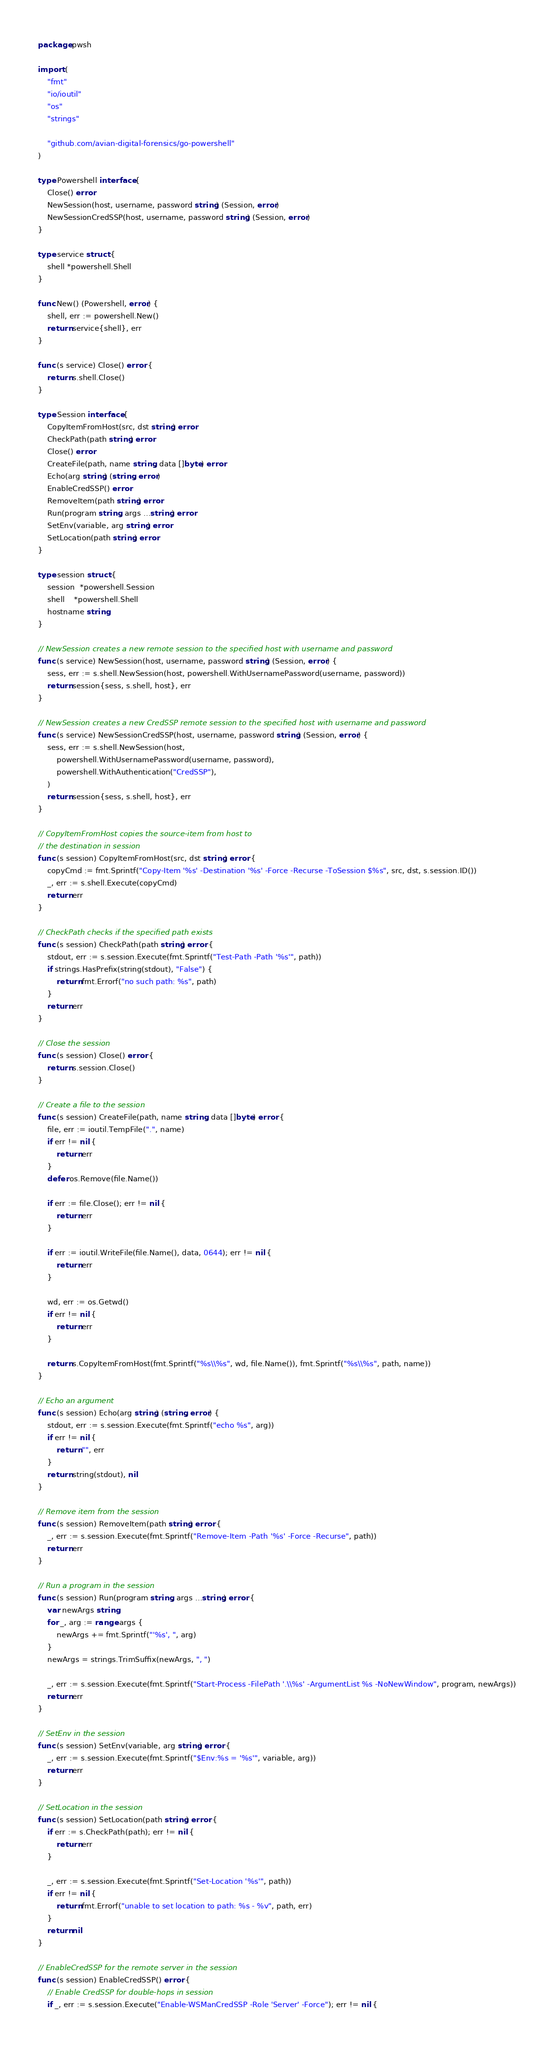<code> <loc_0><loc_0><loc_500><loc_500><_Go_>package pwsh

import (
	"fmt"
	"io/ioutil"
	"os"
	"strings"

	"github.com/avian-digital-forensics/go-powershell"
)

type Powershell interface {
	Close() error
	NewSession(host, username, password string) (Session, error)
	NewSessionCredSSP(host, username, password string) (Session, error)
}

type service struct {
	shell *powershell.Shell
}

func New() (Powershell, error) {
	shell, err := powershell.New()
	return service{shell}, err
}

func (s service) Close() error {
	return s.shell.Close()
}

type Session interface {
	CopyItemFromHost(src, dst string) error
	CheckPath(path string) error
	Close() error
	CreateFile(path, name string, data []byte) error
	Echo(arg string) (string, error)
	EnableCredSSP() error
	RemoveItem(path string) error
	Run(program string, args ...string) error
	SetEnv(variable, arg string) error
	SetLocation(path string) error
}

type session struct {
	session  *powershell.Session
	shell    *powershell.Shell
	hostname string
}

// NewSession creates a new remote session to the specified host with username and password
func (s service) NewSession(host, username, password string) (Session, error) {
	sess, err := s.shell.NewSession(host, powershell.WithUsernamePassword(username, password))
	return session{sess, s.shell, host}, err
}

// NewSession creates a new CredSSP remote session to the specified host with username and password
func (s service) NewSessionCredSSP(host, username, password string) (Session, error) {
	sess, err := s.shell.NewSession(host,
		powershell.WithUsernamePassword(username, password),
		powershell.WithAuthentication("CredSSP"),
	)
	return session{sess, s.shell, host}, err
}

// CopyItemFromHost copies the source-item from host to
// the destination in session
func (s session) CopyItemFromHost(src, dst string) error {
	copyCmd := fmt.Sprintf("Copy-Item '%s' -Destination '%s' -Force -Recurse -ToSession $%s", src, dst, s.session.ID())
	_, err := s.shell.Execute(copyCmd)
	return err
}

// CheckPath checks if the specified path exists
func (s session) CheckPath(path string) error {
	stdout, err := s.session.Execute(fmt.Sprintf("Test-Path -Path '%s'", path))
	if strings.HasPrefix(string(stdout), "False") {
		return fmt.Errorf("no such path: %s", path)
	}
	return err
}

// Close the session
func (s session) Close() error {
	return s.session.Close()
}

// Create a file to the session
func (s session) CreateFile(path, name string, data []byte) error {
	file, err := ioutil.TempFile(".", name)
	if err != nil {
		return err
	}
	defer os.Remove(file.Name())

	if err := file.Close(); err != nil {
		return err
	}

	if err := ioutil.WriteFile(file.Name(), data, 0644); err != nil {
		return err
	}

	wd, err := os.Getwd()
	if err != nil {
		return err
	}

	return s.CopyItemFromHost(fmt.Sprintf("%s\\%s", wd, file.Name()), fmt.Sprintf("%s\\%s", path, name))
}

// Echo an argument
func (s session) Echo(arg string) (string, error) {
	stdout, err := s.session.Execute(fmt.Sprintf("echo %s", arg))
	if err != nil {
		return "", err
	}
	return string(stdout), nil
}

// Remove item from the session
func (s session) RemoveItem(path string) error {
	_, err := s.session.Execute(fmt.Sprintf("Remove-Item -Path '%s' -Force -Recurse", path))
	return err
}

// Run a program in the session
func (s session) Run(program string, args ...string) error {
	var newArgs string
	for _, arg := range args {
		newArgs += fmt.Sprintf("'%s', ", arg)
	}
	newArgs = strings.TrimSuffix(newArgs, ", ")

	_, err := s.session.Execute(fmt.Sprintf("Start-Process -FilePath '.\\%s' -ArgumentList %s -NoNewWindow", program, newArgs))
	return err
}

// SetEnv in the session
func (s session) SetEnv(variable, arg string) error {
	_, err := s.session.Execute(fmt.Sprintf("$Env:%s = '%s'", variable, arg))
	return err
}

// SetLocation in the session
func (s session) SetLocation(path string) error {
	if err := s.CheckPath(path); err != nil {
		return err
	}

	_, err := s.session.Execute(fmt.Sprintf("Set-Location '%s'", path))
	if err != nil {
		return fmt.Errorf("unable to set location to path: %s - %v", path, err)
	}
	return nil
}

// EnableCredSSP for the remote server in the session
func (s session) EnableCredSSP() error {
	// Enable CredSSP for double-hops in session
	if _, err := s.session.Execute("Enable-WSManCredSSP -Role 'Server' -Force"); err != nil {</code> 